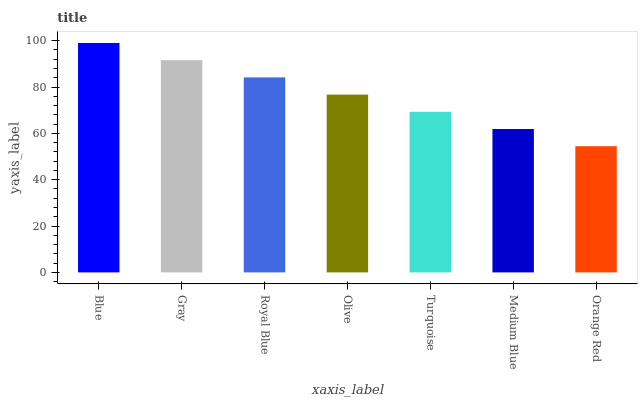Is Gray the minimum?
Answer yes or no. No. Is Gray the maximum?
Answer yes or no. No. Is Blue greater than Gray?
Answer yes or no. Yes. Is Gray less than Blue?
Answer yes or no. Yes. Is Gray greater than Blue?
Answer yes or no. No. Is Blue less than Gray?
Answer yes or no. No. Is Olive the high median?
Answer yes or no. Yes. Is Olive the low median?
Answer yes or no. Yes. Is Gray the high median?
Answer yes or no. No. Is Turquoise the low median?
Answer yes or no. No. 